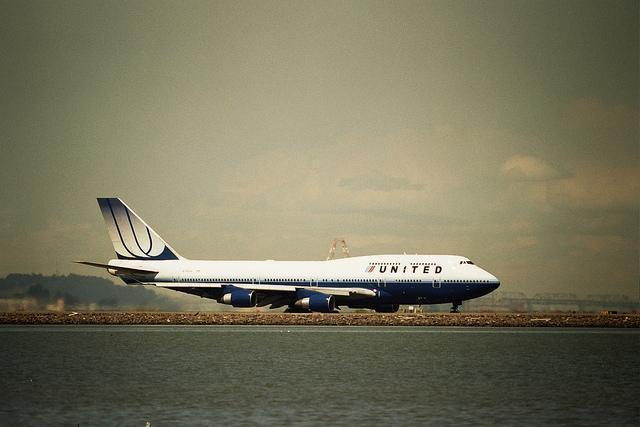How many supports does the bench have?
Give a very brief answer. 0. 